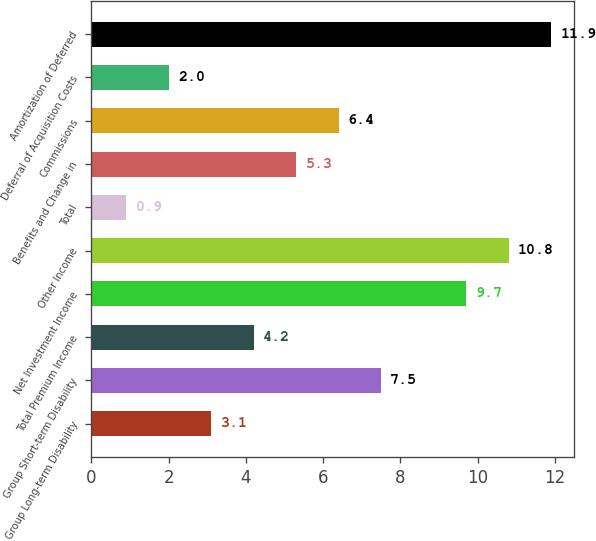<chart> <loc_0><loc_0><loc_500><loc_500><bar_chart><fcel>Group Long-term Disability<fcel>Group Short-term Disability<fcel>Total Premium Income<fcel>Net Investment Income<fcel>Other Income<fcel>Total<fcel>Benefits and Change in<fcel>Commissions<fcel>Deferral of Acquisition Costs<fcel>Amortization of Deferred<nl><fcel>3.1<fcel>7.5<fcel>4.2<fcel>9.7<fcel>10.8<fcel>0.9<fcel>5.3<fcel>6.4<fcel>2<fcel>11.9<nl></chart> 